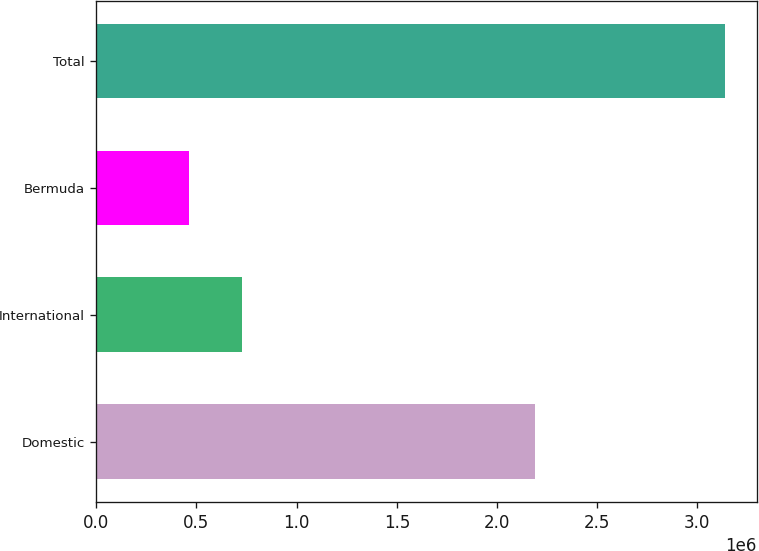<chart> <loc_0><loc_0><loc_500><loc_500><bar_chart><fcel>Domestic<fcel>International<fcel>Bermuda<fcel>Total<nl><fcel>2.19117e+06<fcel>729681<fcel>461909<fcel>3.13963e+06<nl></chart> 